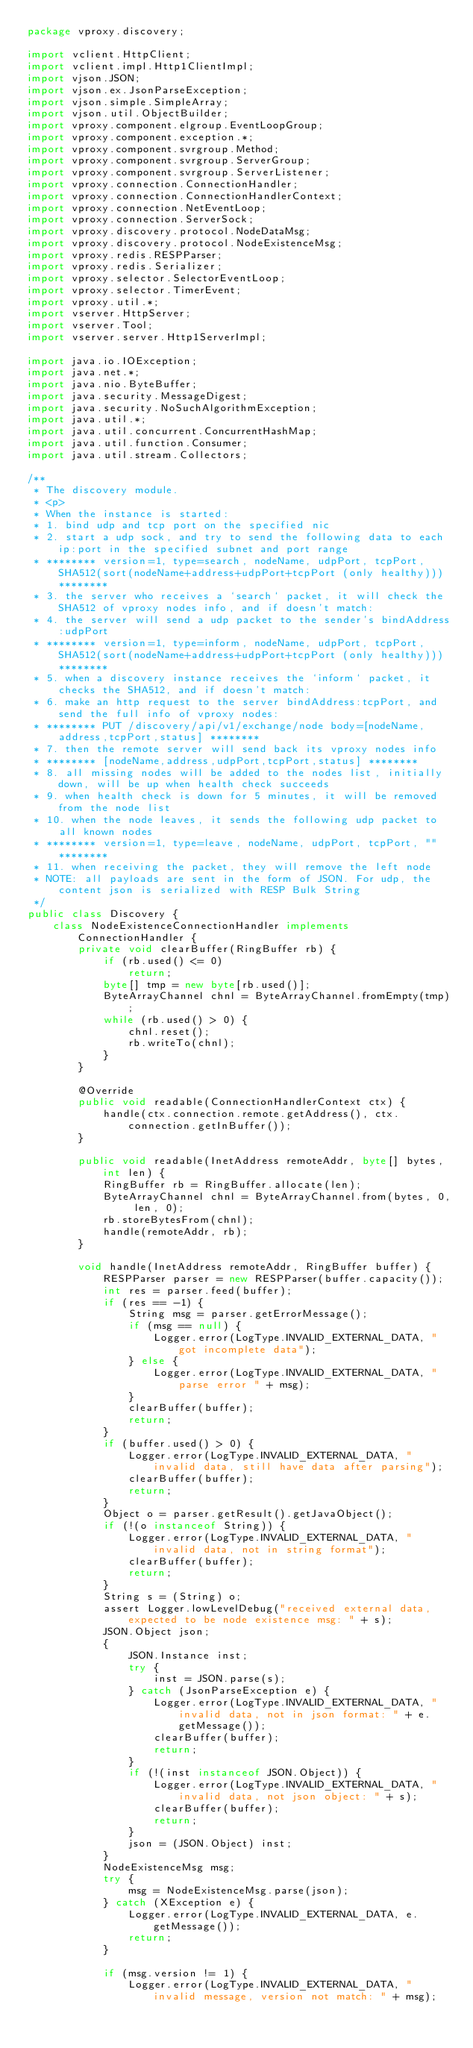<code> <loc_0><loc_0><loc_500><loc_500><_Java_>package vproxy.discovery;

import vclient.HttpClient;
import vclient.impl.Http1ClientImpl;
import vjson.JSON;
import vjson.ex.JsonParseException;
import vjson.simple.SimpleArray;
import vjson.util.ObjectBuilder;
import vproxy.component.elgroup.EventLoopGroup;
import vproxy.component.exception.*;
import vproxy.component.svrgroup.Method;
import vproxy.component.svrgroup.ServerGroup;
import vproxy.component.svrgroup.ServerListener;
import vproxy.connection.ConnectionHandler;
import vproxy.connection.ConnectionHandlerContext;
import vproxy.connection.NetEventLoop;
import vproxy.connection.ServerSock;
import vproxy.discovery.protocol.NodeDataMsg;
import vproxy.discovery.protocol.NodeExistenceMsg;
import vproxy.redis.RESPParser;
import vproxy.redis.Serializer;
import vproxy.selector.SelectorEventLoop;
import vproxy.selector.TimerEvent;
import vproxy.util.*;
import vserver.HttpServer;
import vserver.Tool;
import vserver.server.Http1ServerImpl;

import java.io.IOException;
import java.net.*;
import java.nio.ByteBuffer;
import java.security.MessageDigest;
import java.security.NoSuchAlgorithmException;
import java.util.*;
import java.util.concurrent.ConcurrentHashMap;
import java.util.function.Consumer;
import java.util.stream.Collectors;

/**
 * The discovery module.
 * <p>
 * When the instance is started:
 * 1. bind udp and tcp port on the specified nic
 * 2. start a udp sock, and try to send the following data to each ip:port in the specified subnet and port range
 * ******** version=1, type=search, nodeName, udpPort, tcpPort, SHA512(sort(nodeName+address+udpPort+tcpPort (only healthy))) ********
 * 3. the server who receives a `search` packet, it will check the SHA512 of vproxy nodes info, and if doesn't match:
 * 4. the server will send a udp packet to the sender's bindAddress:udpPort
 * ******** version=1, type=inform, nodeName, udpPort, tcpPort, SHA512(sort(nodeName+address+udpPort+tcpPort (only healthy))) ********
 * 5. when a discovery instance receives the `inform` packet, it checks the SHA512, and if doesn't match:
 * 6. make an http request to the server bindAddress:tcpPort, and send the full info of vproxy nodes:
 * ******** PUT /discovery/api/v1/exchange/node body=[nodeName,address,tcpPort,status] ********
 * 7. then the remote server will send back its vproxy nodes info
 * ******** [nodeName,address,udpPort,tcpPort,status] ********
 * 8. all missing nodes will be added to the nodes list, initially down, will be up when health check succeeds
 * 9. when health check is down for 5 minutes, it will be removed from the node list
 * 10. when the node leaves, it sends the following udp packet to all known nodes
 * ******** version=1, type=leave, nodeName, udpPort, tcpPort, "" ********
 * 11. when receiving the packet, they will remove the left node
 * NOTE: all payloads are sent in the form of JSON. For udp, the content json is serialized with RESP Bulk String
 */
public class Discovery {
    class NodeExistenceConnectionHandler implements ConnectionHandler {
        private void clearBuffer(RingBuffer rb) {
            if (rb.used() <= 0)
                return;
            byte[] tmp = new byte[rb.used()];
            ByteArrayChannel chnl = ByteArrayChannel.fromEmpty(tmp);
            while (rb.used() > 0) {
                chnl.reset();
                rb.writeTo(chnl);
            }
        }

        @Override
        public void readable(ConnectionHandlerContext ctx) {
            handle(ctx.connection.remote.getAddress(), ctx.connection.getInBuffer());
        }

        public void readable(InetAddress remoteAddr, byte[] bytes, int len) {
            RingBuffer rb = RingBuffer.allocate(len);
            ByteArrayChannel chnl = ByteArrayChannel.from(bytes, 0, len, 0);
            rb.storeBytesFrom(chnl);
            handle(remoteAddr, rb);
        }

        void handle(InetAddress remoteAddr, RingBuffer buffer) {
            RESPParser parser = new RESPParser(buffer.capacity());
            int res = parser.feed(buffer);
            if (res == -1) {
                String msg = parser.getErrorMessage();
                if (msg == null) {
                    Logger.error(LogType.INVALID_EXTERNAL_DATA, "got incomplete data");
                } else {
                    Logger.error(LogType.INVALID_EXTERNAL_DATA, "parse error " + msg);
                }
                clearBuffer(buffer);
                return;
            }
            if (buffer.used() > 0) {
                Logger.error(LogType.INVALID_EXTERNAL_DATA, "invalid data, still have data after parsing");
                clearBuffer(buffer);
                return;
            }
            Object o = parser.getResult().getJavaObject();
            if (!(o instanceof String)) {
                Logger.error(LogType.INVALID_EXTERNAL_DATA, "invalid data, not in string format");
                clearBuffer(buffer);
                return;
            }
            String s = (String) o;
            assert Logger.lowLevelDebug("received external data, expected to be node existence msg: " + s);
            JSON.Object json;
            {
                JSON.Instance inst;
                try {
                    inst = JSON.parse(s);
                } catch (JsonParseException e) {
                    Logger.error(LogType.INVALID_EXTERNAL_DATA, "invalid data, not in json format: " + e.getMessage());
                    clearBuffer(buffer);
                    return;
                }
                if (!(inst instanceof JSON.Object)) {
                    Logger.error(LogType.INVALID_EXTERNAL_DATA, "invalid data, not json object: " + s);
                    clearBuffer(buffer);
                    return;
                }
                json = (JSON.Object) inst;
            }
            NodeExistenceMsg msg;
            try {
                msg = NodeExistenceMsg.parse(json);
            } catch (XException e) {
                Logger.error(LogType.INVALID_EXTERNAL_DATA, e.getMessage());
                return;
            }

            if (msg.version != 1) {
                Logger.error(LogType.INVALID_EXTERNAL_DATA, "invalid message, version not match: " + msg);</code> 